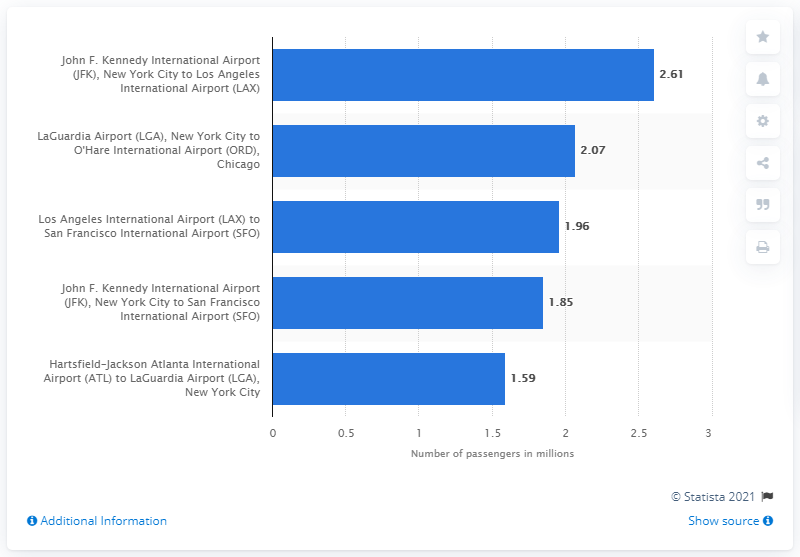Point out several critical features in this image. In 2013, approximately 2,610 passengers traveled from John F. Kennedy International Airport (JFK) to Los Angeles International Airport (LAX). 